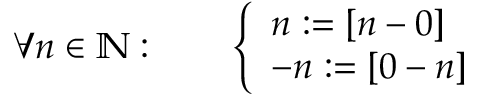Convert formula to latex. <formula><loc_0><loc_0><loc_500><loc_500>\forall n \in \mathbb { N } \colon \quad { \left \{ \begin{array} { l l } { n \colon = [ n - 0 ] } \\ { - n \colon = [ 0 - n ] } \end{array} }</formula> 